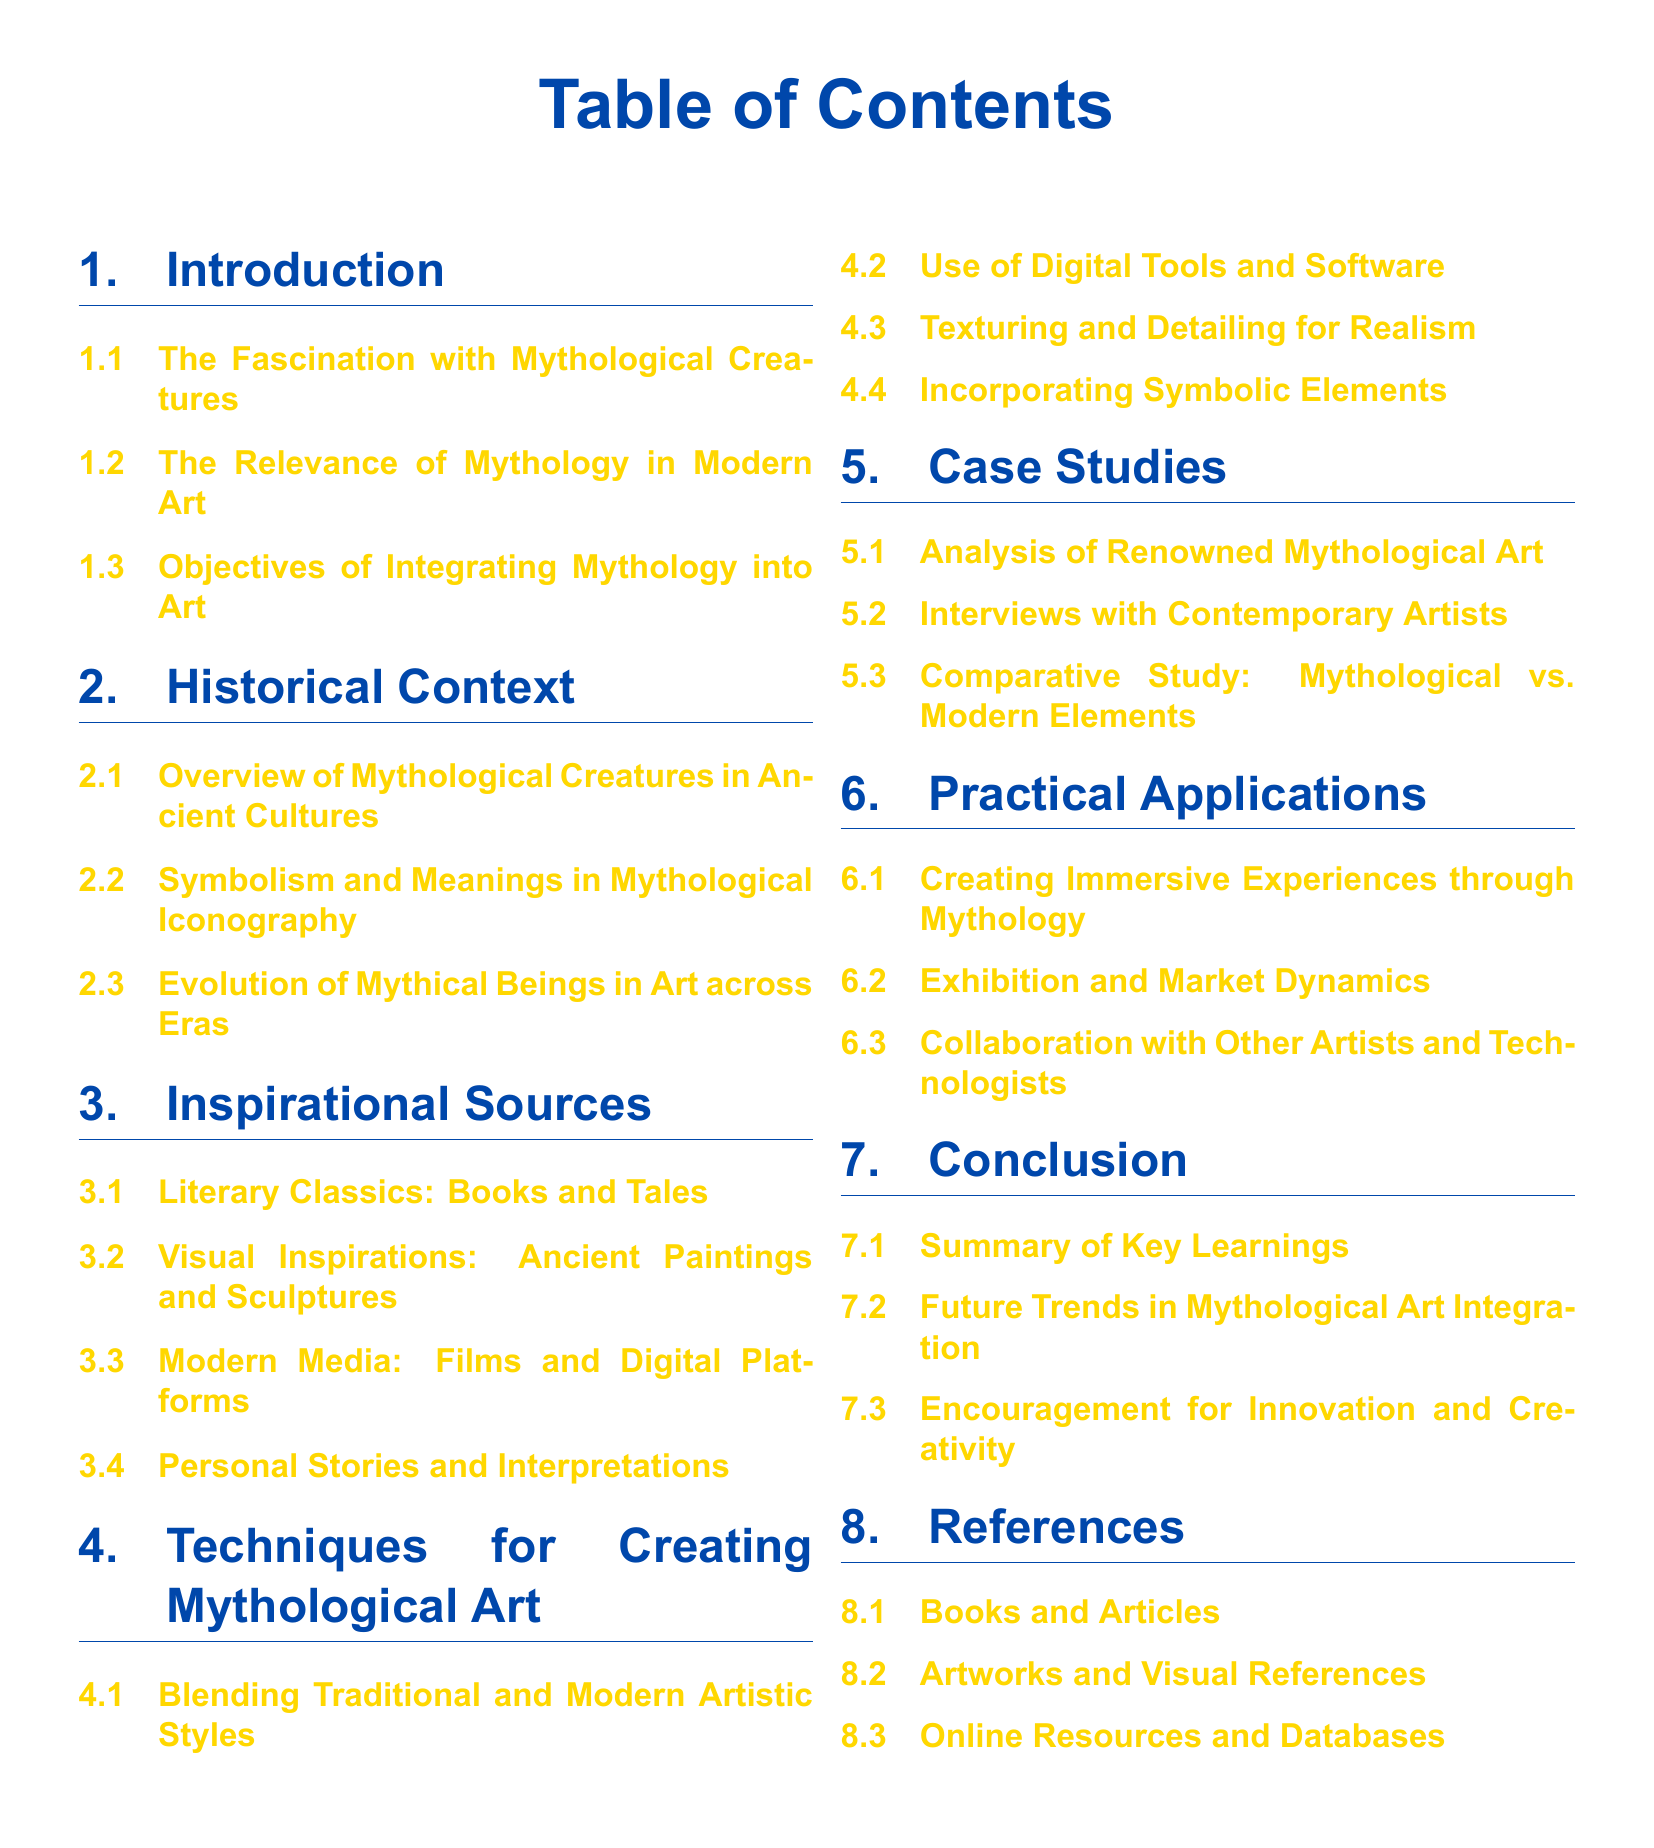What is the first section in the document? The first section is titled "Introduction," which appears at the top of the Table of Contents.
Answer: Introduction How many subsections are under the section "Techniques for Creating Mythological Art"? There are four subsections listed under that section, which can be counted directly from the document.
Answer: 4 What color is used for the section titles? Section titles are displayed in a specific shade of blue, identified in the document as "mythblue."
Answer: mythblue What type of content can be found in the "Practical Applications" section? The "Practical Applications" section contains three subsections that explore various practical uses of integrating mythology into art.
Answer: Creating Immersive Experiences through Mythology, Exhibition and Market Dynamics, Collaboration with Other Artists and Technologists Which section includes interviews with contemporary artists? Interviews with contemporary artists are found in the "Case Studies" section of the document.
Answer: Case Studies How many main sections are included in the document? The document outlines a total of seven main sections, which are enumerated in the Table of Contents.
Answer: 7 What is the last subsection in the "Conclusion" section? The last subsection is titled "Encouragement for Innovation and Creativity," which concludes the context of the document.
Answer: Encouragement for Innovation and Creativity What is the relevance of mythology in modern art? The relevance is discussed in the subsection "The Relevance of Mythology in Modern Art" under the "Introduction" section.
Answer: The Relevance of Mythology in Modern Art 